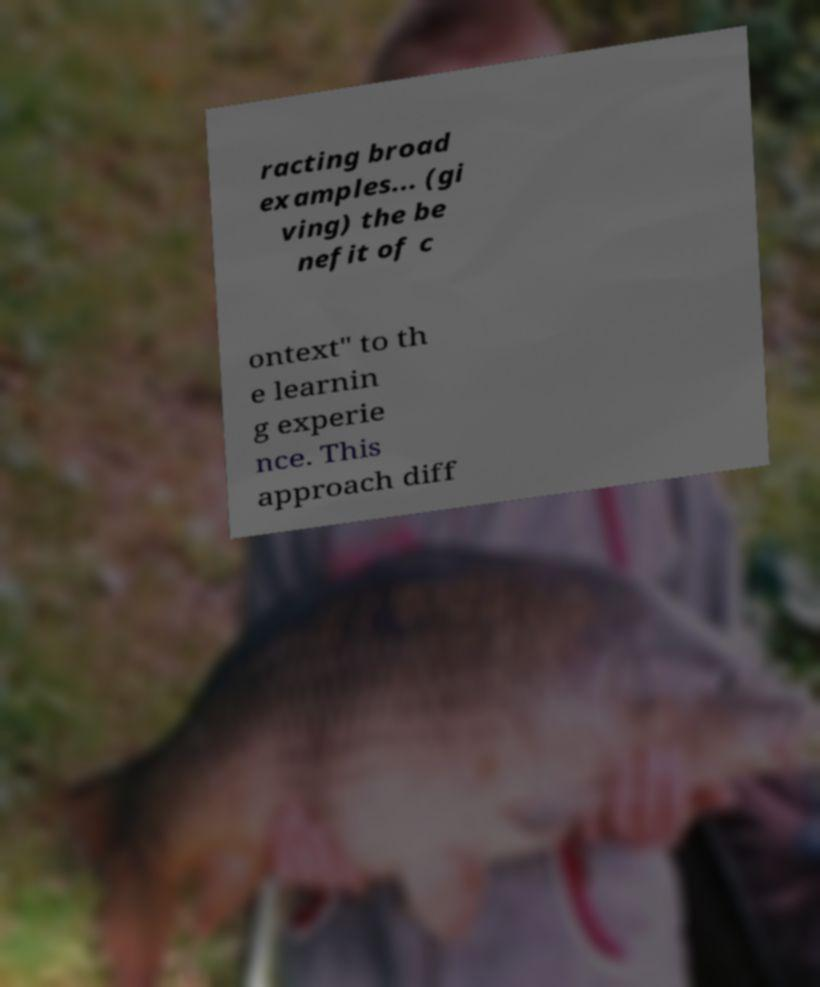For documentation purposes, I need the text within this image transcribed. Could you provide that? racting broad examples... (gi ving) the be nefit of c ontext" to th e learnin g experie nce. This approach diff 